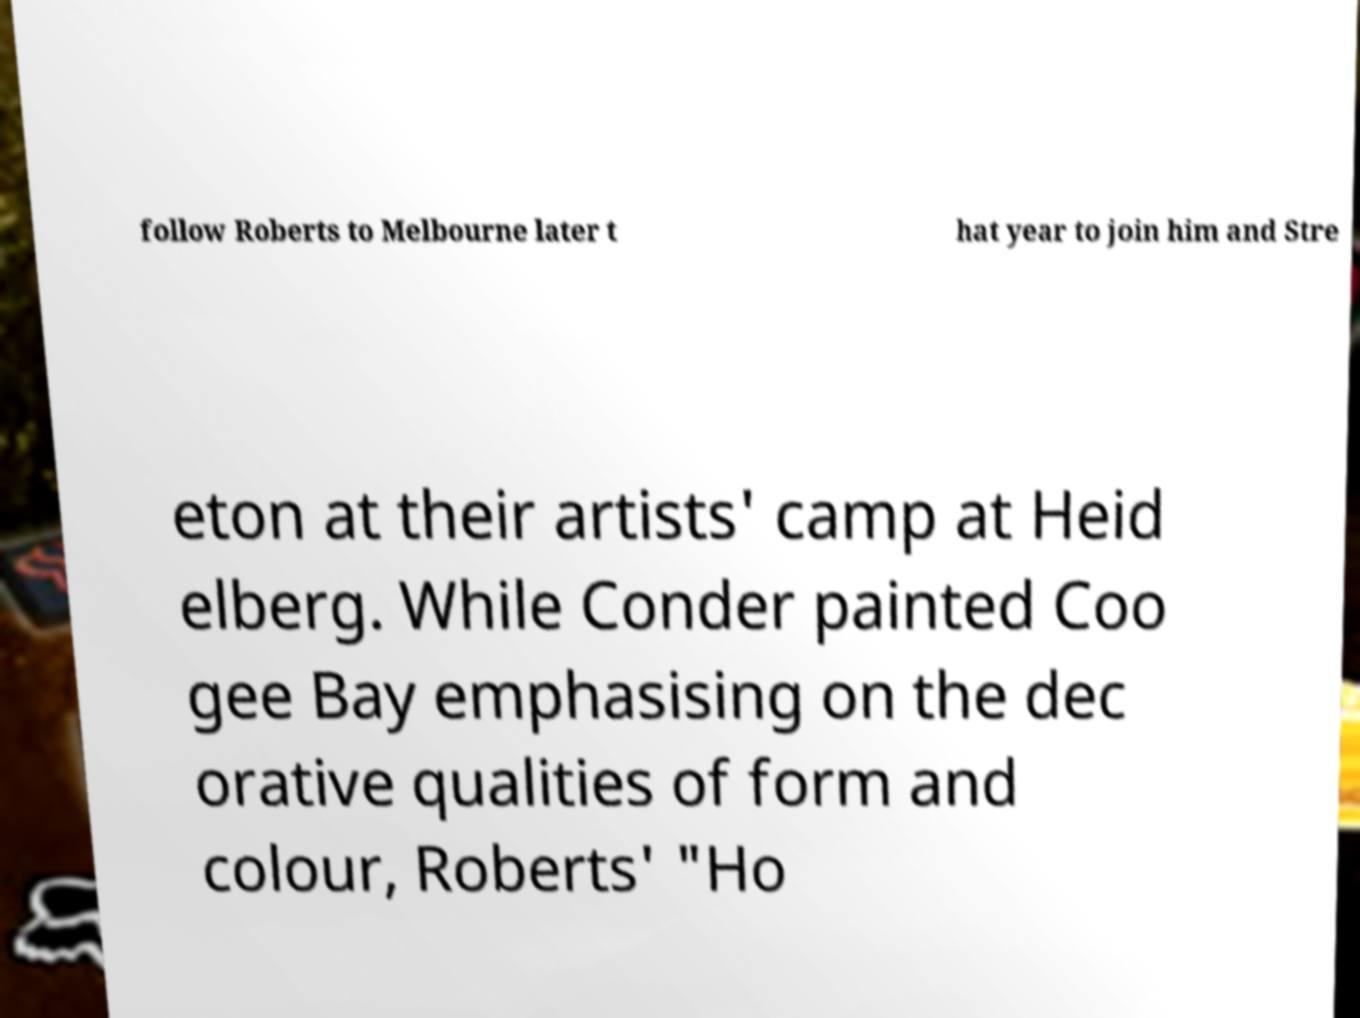Can you read and provide the text displayed in the image?This photo seems to have some interesting text. Can you extract and type it out for me? follow Roberts to Melbourne later t hat year to join him and Stre eton at their artists' camp at Heid elberg. While Conder painted Coo gee Bay emphasising on the dec orative qualities of form and colour, Roberts' "Ho 